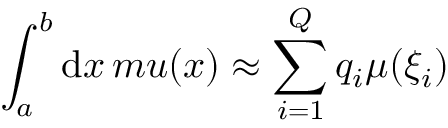Convert formula to latex. <formula><loc_0><loc_0><loc_500><loc_500>\int _ { a } ^ { b } d x \, m u ( x ) \approx \sum _ { i = 1 } ^ { Q } q _ { i } \mu ( \xi _ { i } )</formula> 